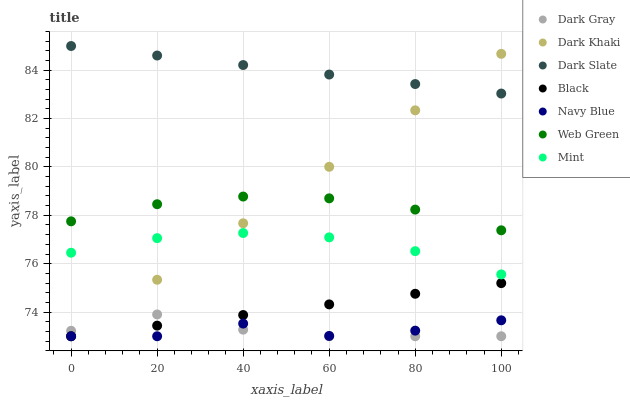Does Navy Blue have the minimum area under the curve?
Answer yes or no. Yes. Does Dark Slate have the maximum area under the curve?
Answer yes or no. Yes. Does Web Green have the minimum area under the curve?
Answer yes or no. No. Does Web Green have the maximum area under the curve?
Answer yes or no. No. Is Dark Khaki the smoothest?
Answer yes or no. Yes. Is Navy Blue the roughest?
Answer yes or no. Yes. Is Web Green the smoothest?
Answer yes or no. No. Is Web Green the roughest?
Answer yes or no. No. Does Dark Khaki have the lowest value?
Answer yes or no. Yes. Does Web Green have the lowest value?
Answer yes or no. No. Does Dark Slate have the highest value?
Answer yes or no. Yes. Does Web Green have the highest value?
Answer yes or no. No. Is Mint less than Web Green?
Answer yes or no. Yes. Is Dark Slate greater than Web Green?
Answer yes or no. Yes. Does Black intersect Dark Khaki?
Answer yes or no. Yes. Is Black less than Dark Khaki?
Answer yes or no. No. Is Black greater than Dark Khaki?
Answer yes or no. No. Does Mint intersect Web Green?
Answer yes or no. No. 